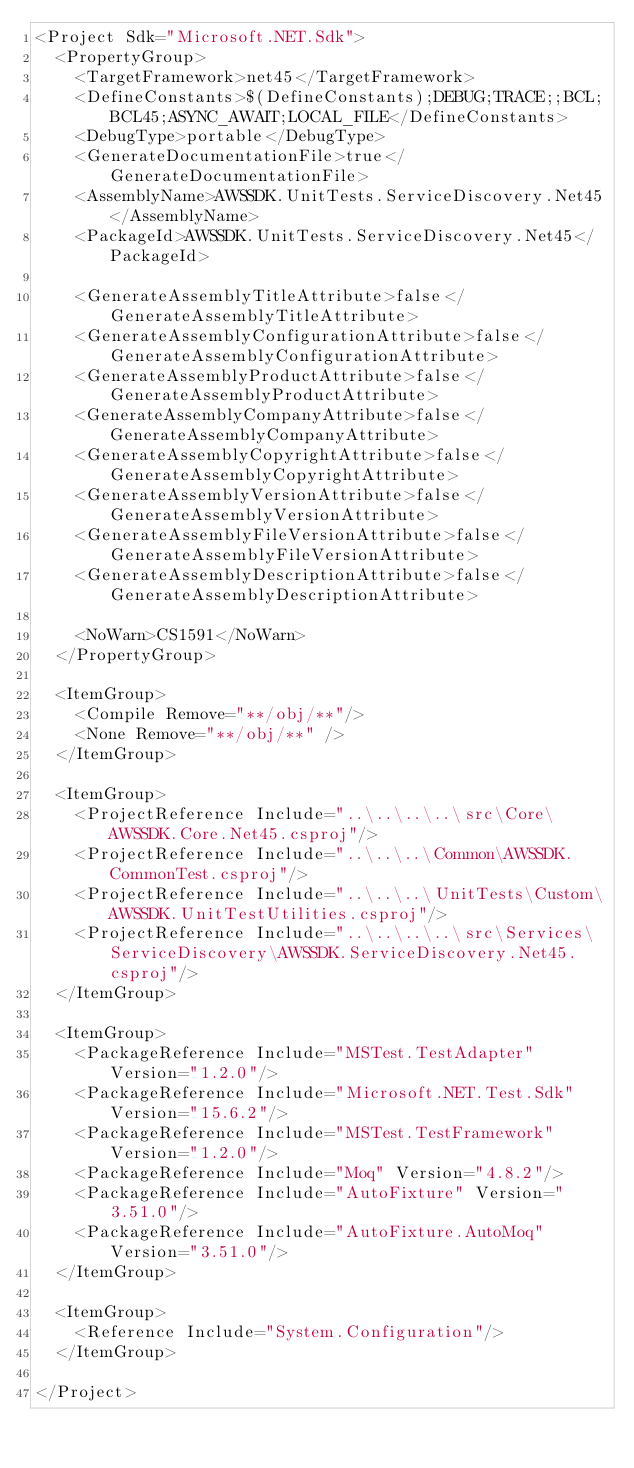<code> <loc_0><loc_0><loc_500><loc_500><_XML_><Project Sdk="Microsoft.NET.Sdk">
  <PropertyGroup>
    <TargetFramework>net45</TargetFramework>
    <DefineConstants>$(DefineConstants);DEBUG;TRACE;;BCL;BCL45;ASYNC_AWAIT;LOCAL_FILE</DefineConstants>
    <DebugType>portable</DebugType>
    <GenerateDocumentationFile>true</GenerateDocumentationFile>
    <AssemblyName>AWSSDK.UnitTests.ServiceDiscovery.Net45</AssemblyName>
    <PackageId>AWSSDK.UnitTests.ServiceDiscovery.Net45</PackageId>

    <GenerateAssemblyTitleAttribute>false</GenerateAssemblyTitleAttribute>
    <GenerateAssemblyConfigurationAttribute>false</GenerateAssemblyConfigurationAttribute>
    <GenerateAssemblyProductAttribute>false</GenerateAssemblyProductAttribute>
    <GenerateAssemblyCompanyAttribute>false</GenerateAssemblyCompanyAttribute>
    <GenerateAssemblyCopyrightAttribute>false</GenerateAssemblyCopyrightAttribute>
    <GenerateAssemblyVersionAttribute>false</GenerateAssemblyVersionAttribute>
    <GenerateAssemblyFileVersionAttribute>false</GenerateAssemblyFileVersionAttribute>
    <GenerateAssemblyDescriptionAttribute>false</GenerateAssemblyDescriptionAttribute>

    <NoWarn>CS1591</NoWarn>
  </PropertyGroup>

  <ItemGroup>
    <Compile Remove="**/obj/**"/>
    <None Remove="**/obj/**" />
  </ItemGroup>

  <ItemGroup>
    <ProjectReference Include="..\..\..\..\src\Core\AWSSDK.Core.Net45.csproj"/>
    <ProjectReference Include="..\..\..\Common\AWSSDK.CommonTest.csproj"/>
    <ProjectReference Include="..\..\..\UnitTests\Custom\AWSSDK.UnitTestUtilities.csproj"/>
    <ProjectReference Include="..\..\..\..\src\Services\ServiceDiscovery\AWSSDK.ServiceDiscovery.Net45.csproj"/>
  </ItemGroup>

  <ItemGroup>
    <PackageReference Include="MSTest.TestAdapter" Version="1.2.0"/>
    <PackageReference Include="Microsoft.NET.Test.Sdk" Version="15.6.2"/>
    <PackageReference Include="MSTest.TestFramework" Version="1.2.0"/>
    <PackageReference Include="Moq" Version="4.8.2"/>
    <PackageReference Include="AutoFixture" Version="3.51.0"/>
    <PackageReference Include="AutoFixture.AutoMoq" Version="3.51.0"/>
  </ItemGroup>

  <ItemGroup>
    <Reference Include="System.Configuration"/>
  </ItemGroup>

</Project></code> 